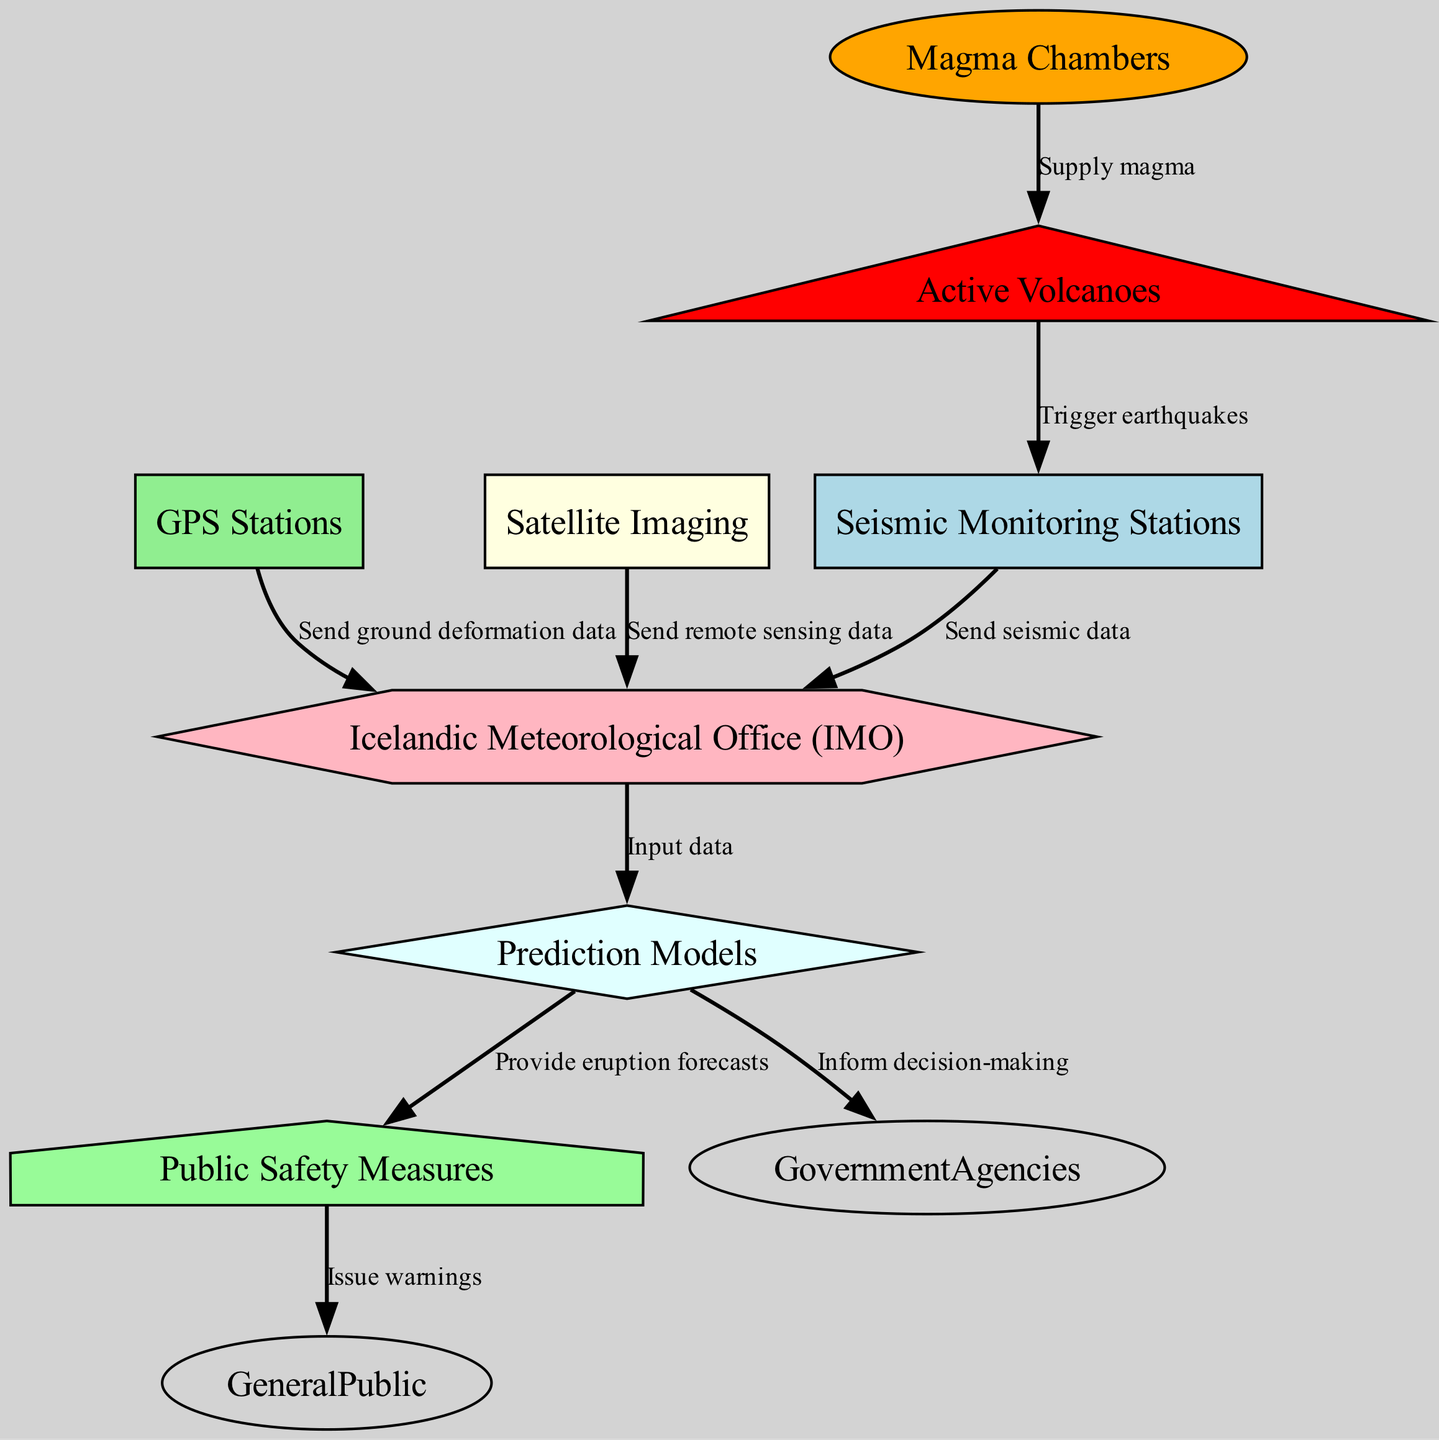What is the node that represents the organization responsible for data analysis? The node labeled "Data Center" represents the Icelandic Meteorological Office (IMO) which is responsible for data analysis. Therefore, by identifying the "Data Center" node in the diagram, we can conclude that this organization plays a key role.
Answer: Data Center How many types of monitoring systems are depicted in the diagram? The diagram shows three types of monitoring systems: Seismic Monitoring Stations, GPS Stations, and Satellite Imaging. Thus, counting these nodes gives us the answer.
Answer: Three Which node issues warnings to the general public? The node labeled "Public Safety Measures" is responsible for issuing warnings to the general public, as indicated by the edge connecting it to the "General Public" node.
Answer: Public Safety Measures What kind of data do the GPS Stations send? GPS Stations send ground deformation data to the Data Center. This relationship is indicated by the labeled edge from the "GPS Stations" node to the "Data Center."
Answer: Ground deformation data What is the output of the prediction models in the diagram? The prediction models provide eruption forecasts as an output, which is depicted in the diagram with a directed edge from "Prediction Models" to "Public Safety." This shows the direct function of these models in regard to safety measures.
Answer: Eruption forecasts How do volcanoes affect seismic monitoring stations? Volcanoes trigger earthquakes as they become active, which is shown in the diagram with an edge from "Volcanoes" to "Seismic Monitoring Stations." This establishes a direct effect of volcanic activity on seismic data collection.
Answer: Trigger earthquakes Which node supplies magma to the volcanoes? The "Magma Chambers" node is the one that supplies magma to the volcanoes according to the diagram, as indicated by the labeled edge connecting these two nodes.
Answer: Magma Chambers How many edges are there in the diagram? The diagram consists of eight directed edges that represent the various relationships between nodes. By counting all the edges shown, we arrive at this number.
Answer: Eight 